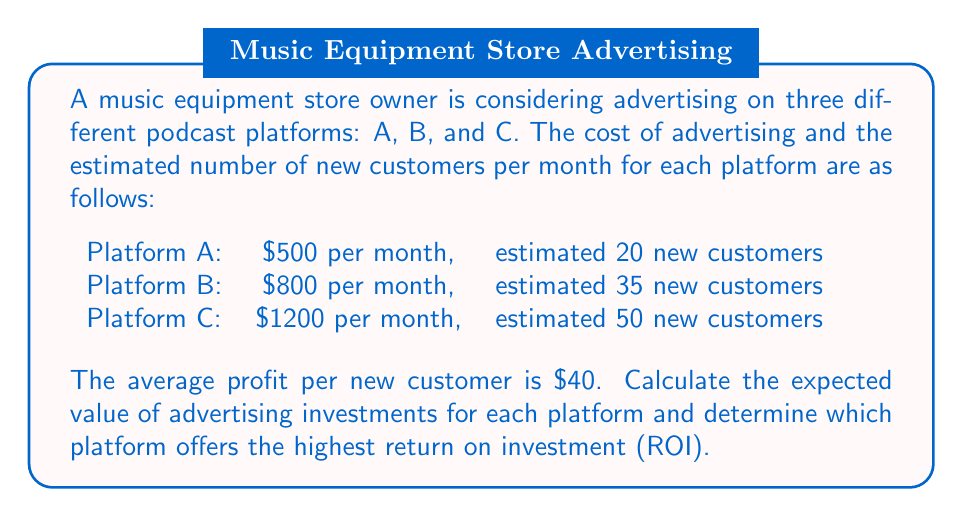Solve this math problem. To solve this problem, we need to calculate the expected value for each platform and compare their ROIs. Let's break it down step by step:

1. Calculate the expected value for each platform:
   Expected Value = (Number of new customers × Profit per customer) - Advertising cost

   Platform A: $E_A = (20 \times \$40) - \$500 = \$300$
   Platform B: $E_B = (35 \times \$40) - \$800 = \$600$
   Platform C: $E_C = (50 \times \$40) - \$1200 = \$800$

2. Calculate the ROI for each platform:
   ROI = (Expected Value / Advertising Cost) × 100%

   Platform A: $ROI_A = (\$300 / \$500) \times 100\% = 60\%$
   Platform B: $ROI_B = (\$600 / \$800) \times 100\% = 75\%$
   Platform C: $ROI_C = (\$800 / \$1200) \times 100\% = 66.67\%$

3. Compare the ROIs:
   Platform B has the highest ROI at 75%, followed by Platform C at 66.67%, and Platform A at 60%.

Therefore, Platform B offers the highest return on investment.
Answer: Platform B offers the highest return on investment with an ROI of 75% and an expected value of $600 per month. 